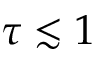Convert formula to latex. <formula><loc_0><loc_0><loc_500><loc_500>\tau \lesssim 1</formula> 